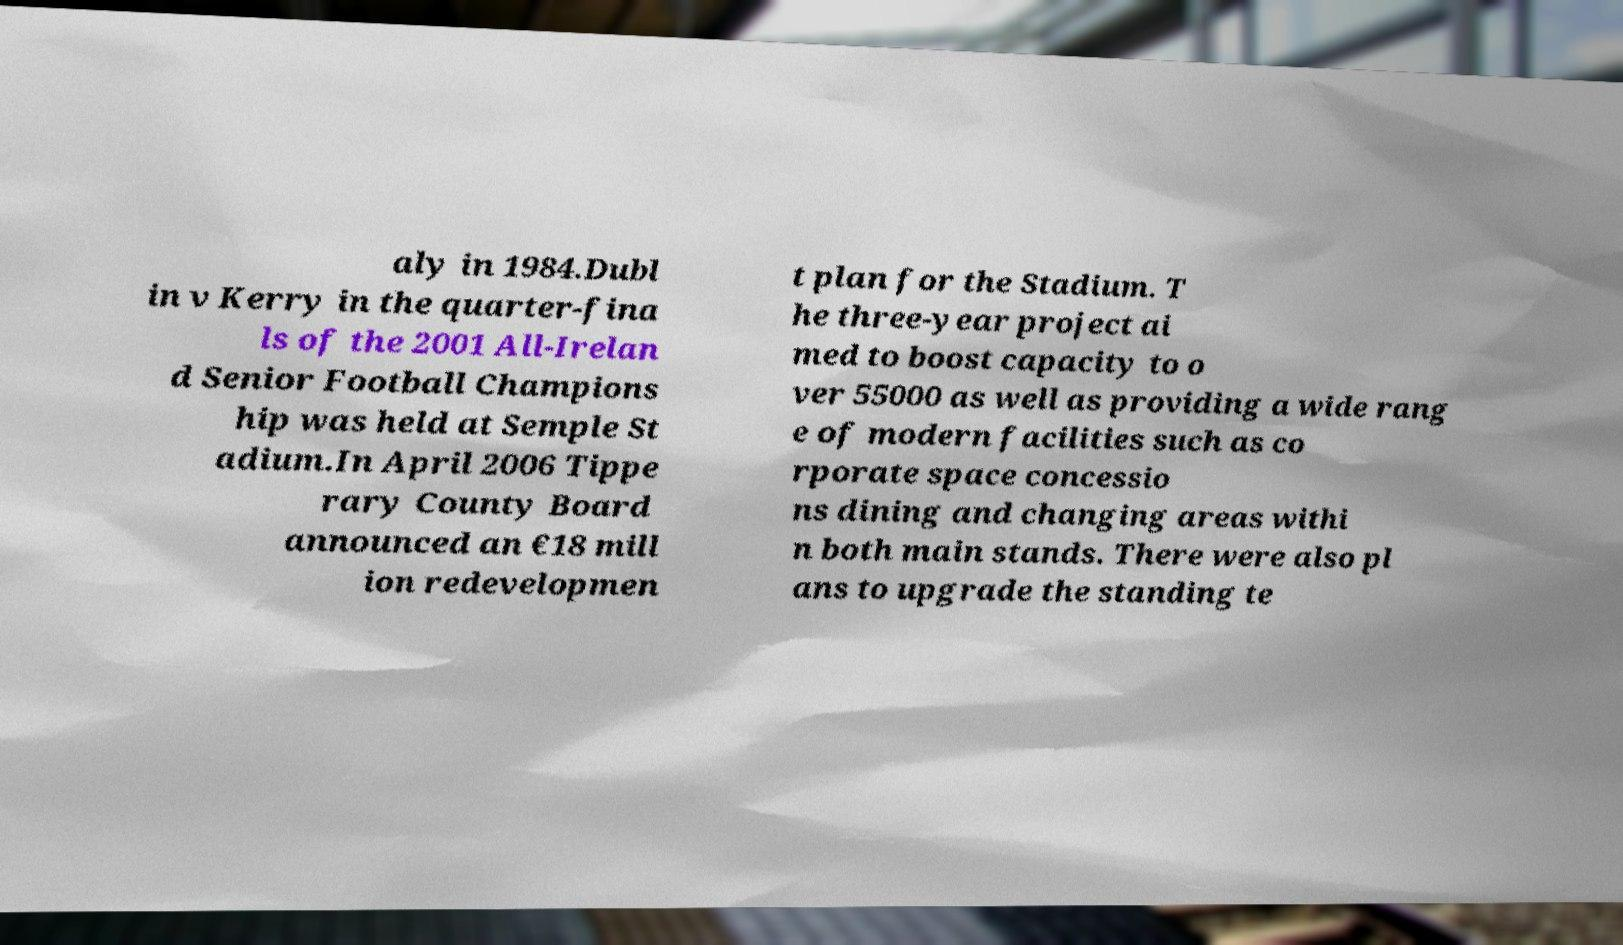I need the written content from this picture converted into text. Can you do that? aly in 1984.Dubl in v Kerry in the quarter-fina ls of the 2001 All-Irelan d Senior Football Champions hip was held at Semple St adium.In April 2006 Tippe rary County Board announced an €18 mill ion redevelopmen t plan for the Stadium. T he three-year project ai med to boost capacity to o ver 55000 as well as providing a wide rang e of modern facilities such as co rporate space concessio ns dining and changing areas withi n both main stands. There were also pl ans to upgrade the standing te 